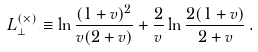Convert formula to latex. <formula><loc_0><loc_0><loc_500><loc_500>L _ { \perp } ^ { ( \times ) } \equiv \ln \frac { ( 1 + v ) ^ { 2 } } { v ( 2 + v ) } + \frac { 2 } { v } \ln \frac { 2 ( 1 + v ) } { 2 + v } \, .</formula> 